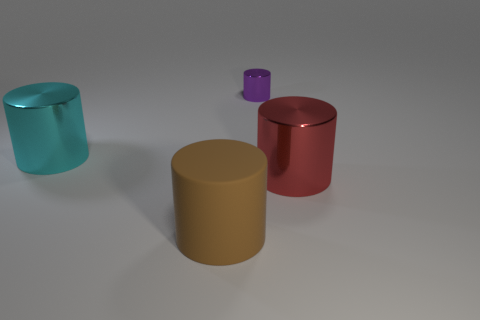How many large matte objects have the same color as the small cylinder?
Your answer should be compact. 0. There is a big thing left of the large object that is in front of the red object; are there any large matte things behind it?
Ensure brevity in your answer.  No. What shape is the cyan thing that is the same size as the red cylinder?
Give a very brief answer. Cylinder. What number of big objects are brown things or red things?
Give a very brief answer. 2. There is a big thing that is the same material as the large red cylinder; what color is it?
Your answer should be very brief. Cyan. Does the large object that is right of the tiny purple metallic thing have the same shape as the object to the left of the rubber cylinder?
Offer a terse response. Yes. What number of rubber objects are large green cylinders or large brown cylinders?
Your answer should be very brief. 1. There is a cylinder that is in front of the large red cylinder; what is its material?
Make the answer very short. Rubber. Does the thing that is behind the cyan metal object have the same material as the brown object?
Provide a succinct answer. No. How many objects are red things or metallic things that are in front of the big cyan object?
Your response must be concise. 1. 